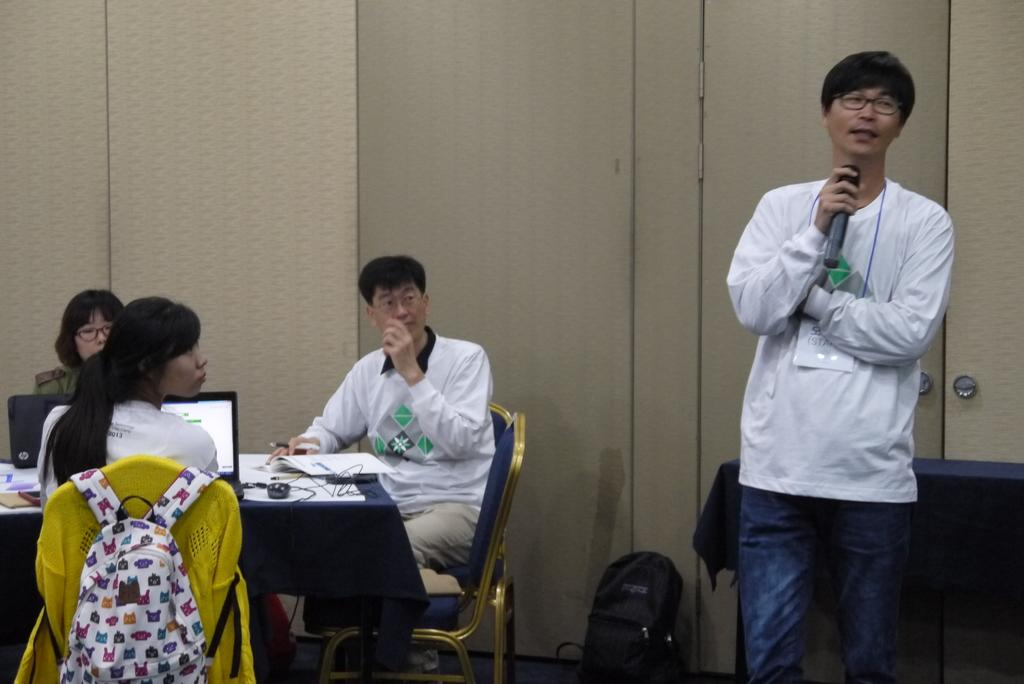What is the main activity of the people in the image? There is a group of persons sitting in the image, which suggests they might be attending an event or gathering. Can you describe the person standing at the right side of the image? The person standing is wearing a white dress and holding a microphone. What might the person standing be doing, given that they are holding a microphone? The person standing might be a speaker or performer, as they are holding a microphone, which is commonly used for amplifying sound. What type of juice is being served in the image? There is no juice present in the image; it features a group of persons sitting and a person standing with a microphone. Can you describe the chin of the person standing in the image? There is no information about the chin of the person standing in the image, as the provided facts do not mention any details about their facial features. 